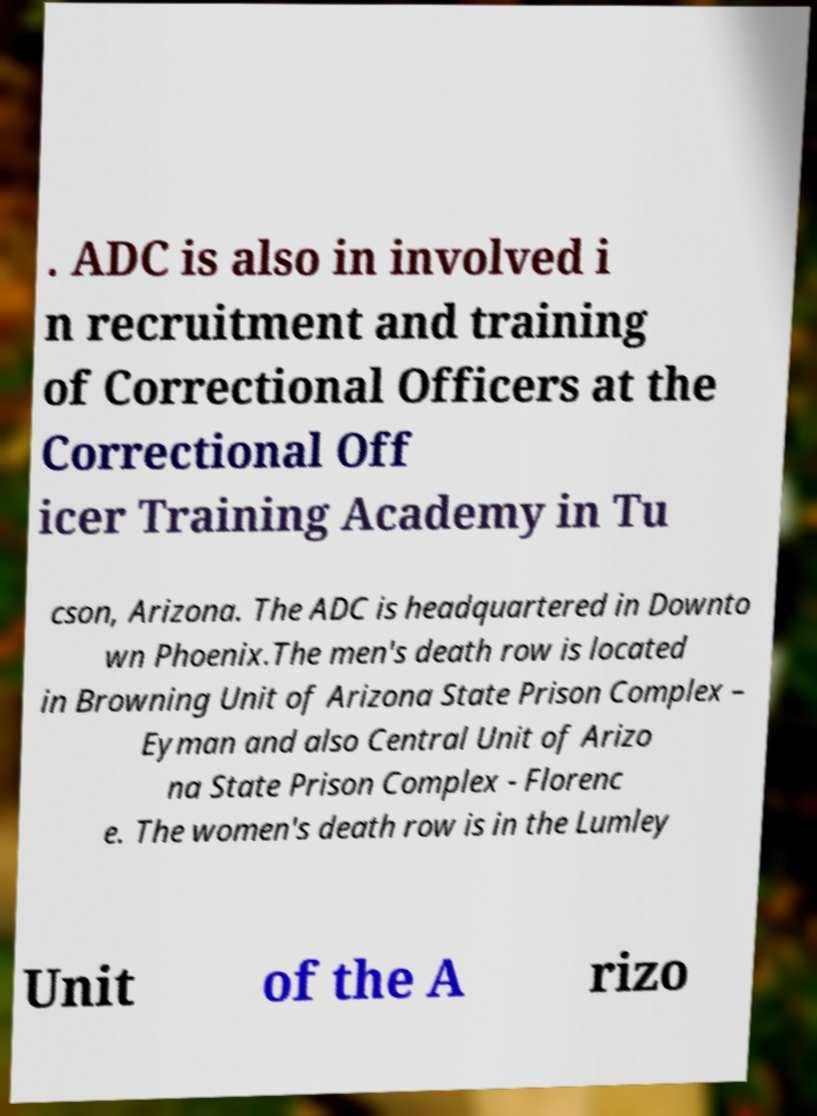Can you accurately transcribe the text from the provided image for me? . ADC is also in involved i n recruitment and training of Correctional Officers at the Correctional Off icer Training Academy in Tu cson, Arizona. The ADC is headquartered in Downto wn Phoenix.The men's death row is located in Browning Unit of Arizona State Prison Complex – Eyman and also Central Unit of Arizo na State Prison Complex - Florenc e. The women's death row is in the Lumley Unit of the A rizo 